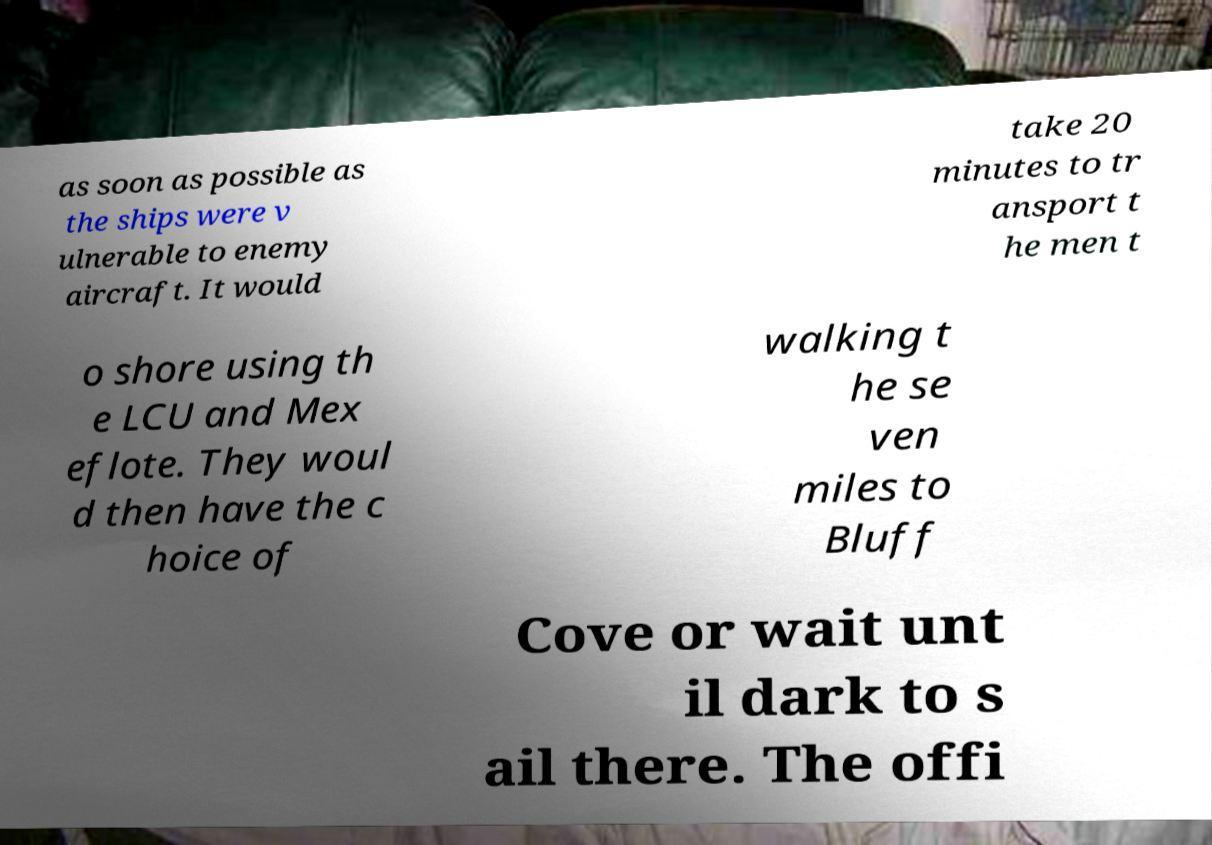Can you read and provide the text displayed in the image?This photo seems to have some interesting text. Can you extract and type it out for me? as soon as possible as the ships were v ulnerable to enemy aircraft. It would take 20 minutes to tr ansport t he men t o shore using th e LCU and Mex eflote. They woul d then have the c hoice of walking t he se ven miles to Bluff Cove or wait unt il dark to s ail there. The offi 